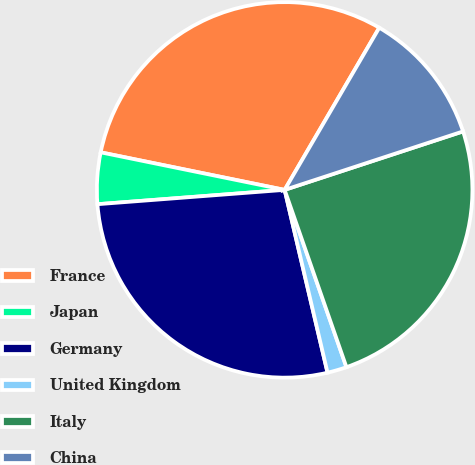<chart> <loc_0><loc_0><loc_500><loc_500><pie_chart><fcel>France<fcel>Japan<fcel>Germany<fcel>United Kingdom<fcel>Italy<fcel>China<nl><fcel>30.2%<fcel>4.42%<fcel>27.45%<fcel>1.67%<fcel>24.7%<fcel>11.55%<nl></chart> 